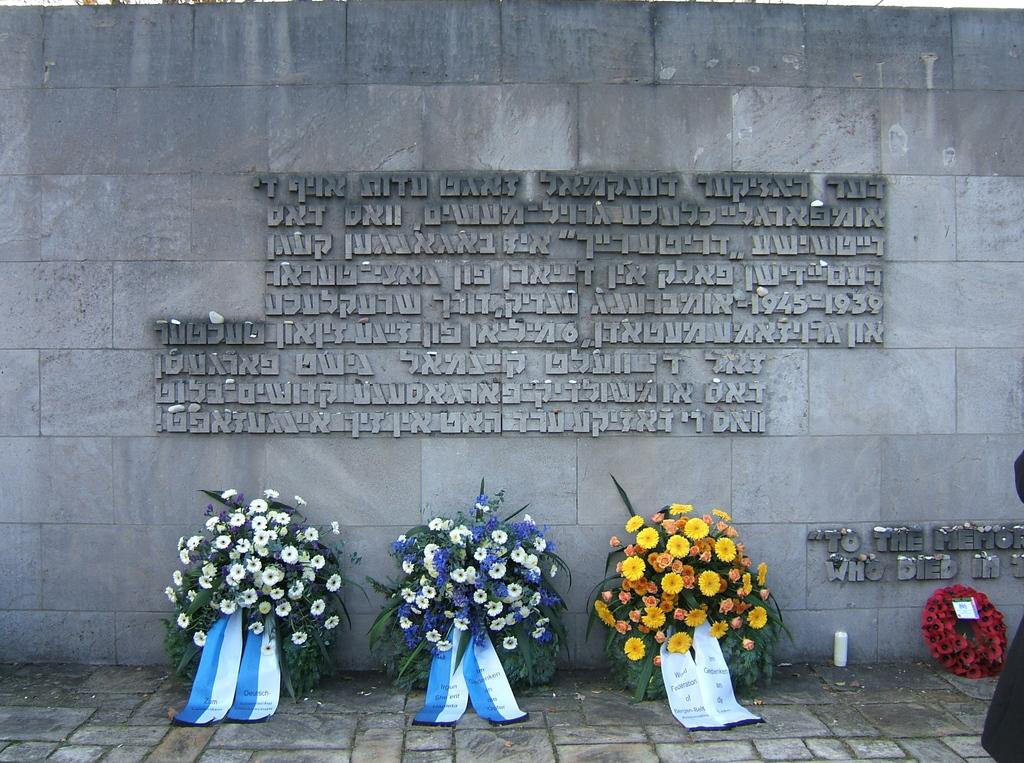What is on the ground in the image? There are flower bouquets on the ground in the image. What colors can be seen in the flower bouquets? The bouquets have various colors, including white, blue, yellow, orange, and red. What is visible in the background of the image? There is a wall in the background of the image. What color is the wall in the image? The wall is ash in color. What type of sound can be heard coming from the top of the wall in the image? There is no sound present in the image, and the top of the wall is not visible. 